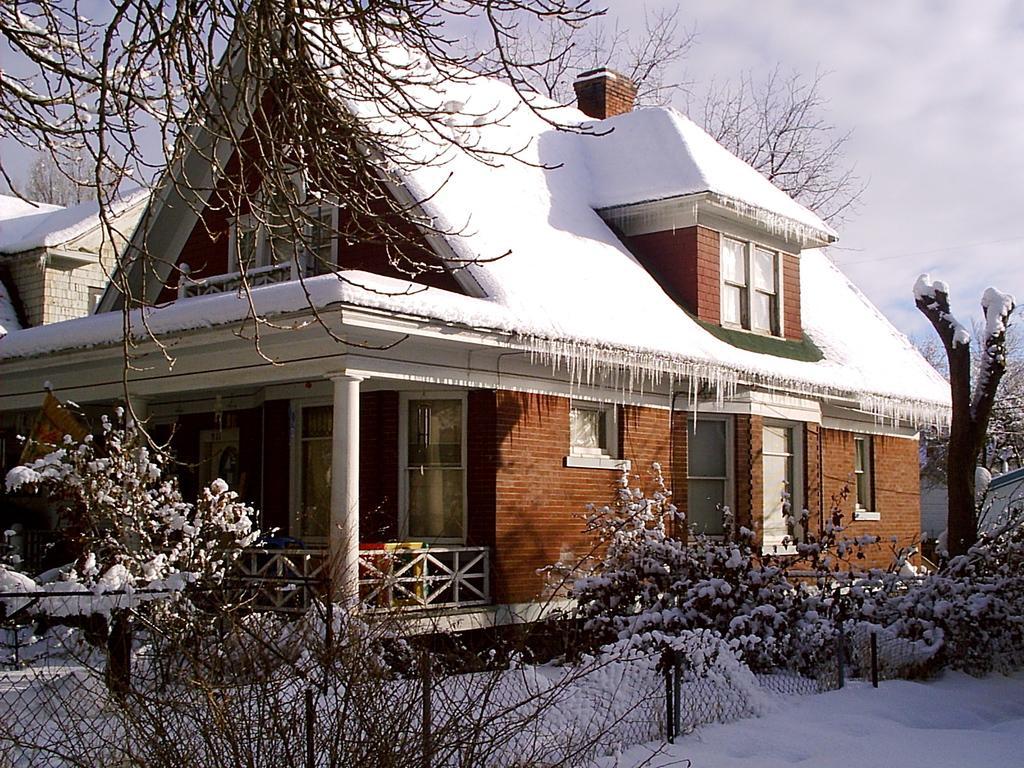Describe this image in one or two sentences. In this picture there is a house constructed with bricks and roof tiles. The house is covered with the snow. On the top left, there is a tree. At the bottom there are plants, fence and a snow. On the top right, there is a sky with clouds. 